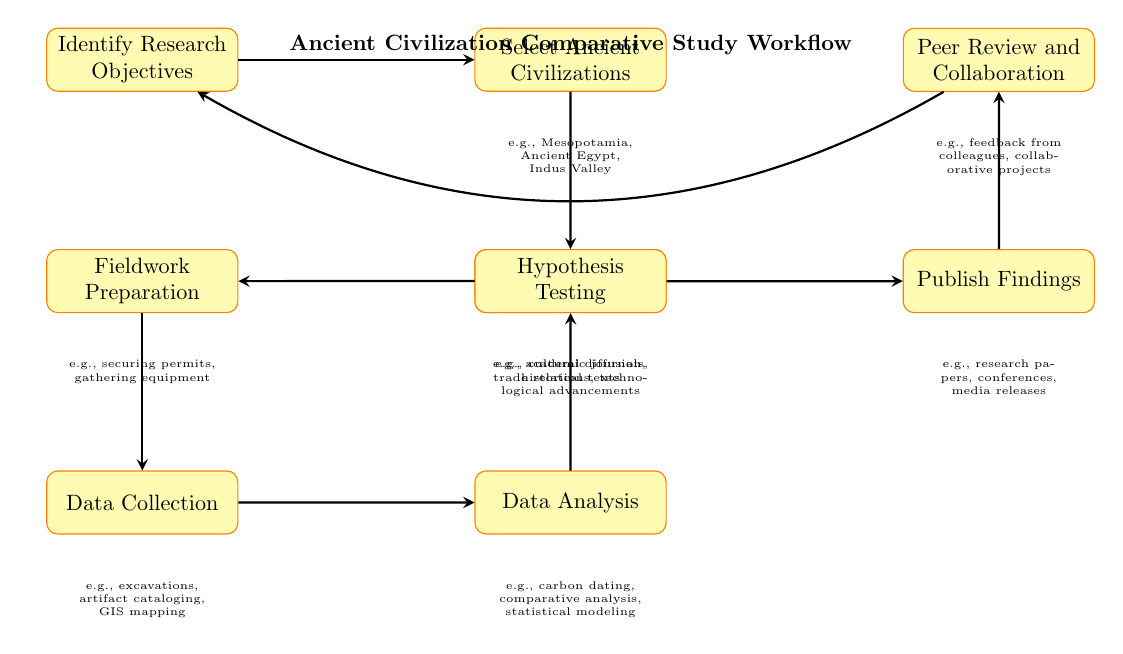What is the first step in the workflow? The diagram starts with the node representing "Identify Research Objectives," which is the first process in the workflow.
Answer: Identify Research Objectives How many nodes are in the diagram? Counting each of the distinct labeled rectangles, there are a total of 9 nodes in the diagram.
Answer: 9 What connects "Data Collection" to "Data Analysis"? The arrow indicates a direct relationship, meaning that after "Data Collection," the next step is "Data Analysis." This shows a sequential flow in the study process.
Answer: Data Analysis What type of tasks does "Hypothesis Testing" involve? The sublabel of "Hypothesis Testing" includes aspects like cultural diffusion, trade relations, and technological advancements, indicating the type of inquiries made during this phase.
Answer: cultural diffusion, trade relations, technological advancements Which step follows "Publish Findings"? The next step listed after "Publish Findings" is "Peer Review and Collaboration," showing that after publishing, researchers often engage in reviewing and collaborating with others.
Answer: Peer Review and Collaboration How do the steps relate to each other in the workflow? Each arrow signifies a progression from one step to the next, implying a structured approach where each task leads into the subsequent task, creating a continuous cycle with "Peer Review and Collaboration" eventually returning to "Identify Research Objectives."
Answer: Continuous cycle What type of analysis is included in "Data Analysis"? The sublabel indicates that "Data Analysis" includes carbon dating, comparative analysis, and statistical modeling, which are specific types of analyses that can be employed during this phase.
Answer: carbon dating, comparative analysis, statistical modeling Which ancient civilizations are suggested for selection? The node labeled "Select Ancient Civilizations" mentions Mesopotamia, Ancient Egypt, and Indus Valley as examples, providing specific civilizations to focus on in the study.
Answer: Mesopotamia, Ancient Egypt, Indus Valley What type of literature is reviewed in the workflow? The node labeled "Literature Review" indicates that this phase would involve reviewing sources such as academic journals and historical texts, which are critical for gathering existing knowledge.
Answer: academic journals, historical texts 